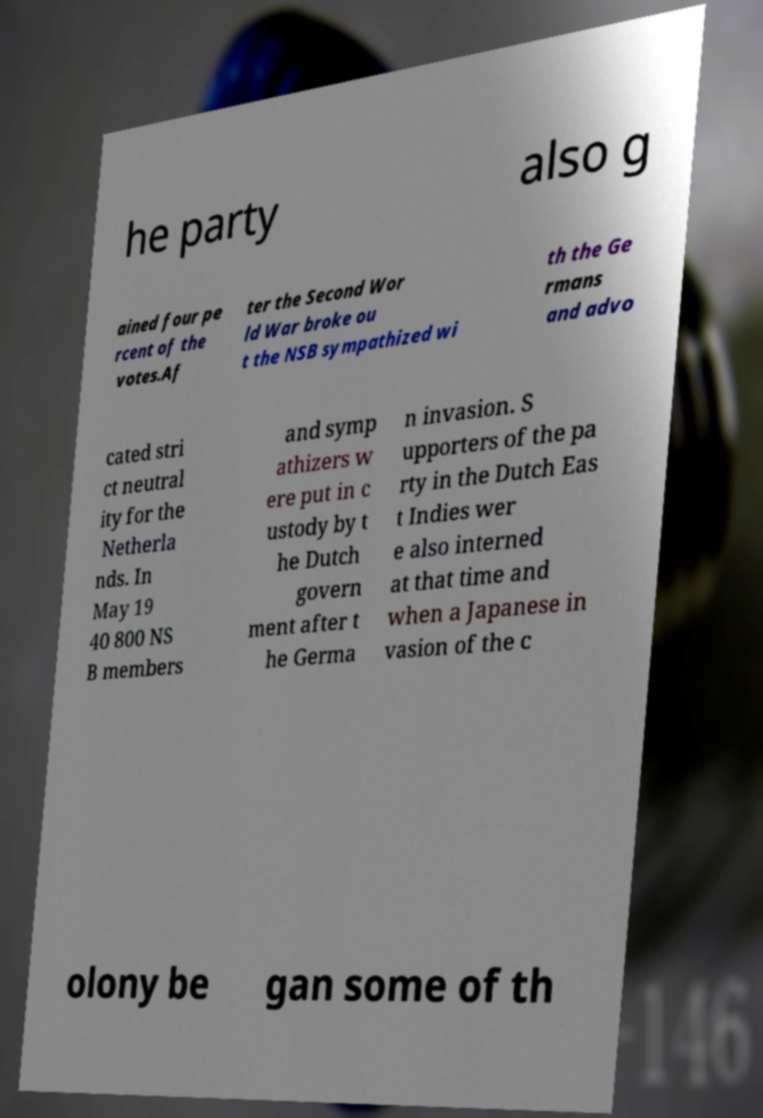For documentation purposes, I need the text within this image transcribed. Could you provide that? he party also g ained four pe rcent of the votes.Af ter the Second Wor ld War broke ou t the NSB sympathized wi th the Ge rmans and advo cated stri ct neutral ity for the Netherla nds. In May 19 40 800 NS B members and symp athizers w ere put in c ustody by t he Dutch govern ment after t he Germa n invasion. S upporters of the pa rty in the Dutch Eas t Indies wer e also interned at that time and when a Japanese in vasion of the c olony be gan some of th 